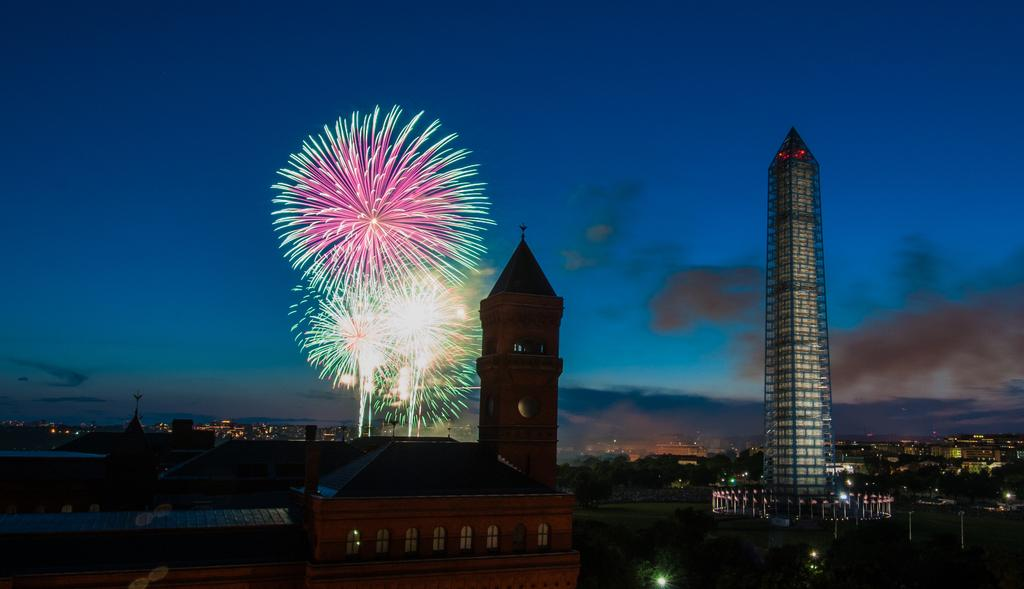What type of structures can be seen in the image? There are buildings in the image. What can be seen illuminating the scene in the image? There are lights visible in the image. What is happening in the background of the image? There are fireworks in the background of the image. What colors are present in the sky in the image? The sky is blue and gray in color. What reason does the boat have for being in the image? There is no boat present in the image, so there is no reason for it to be there. 